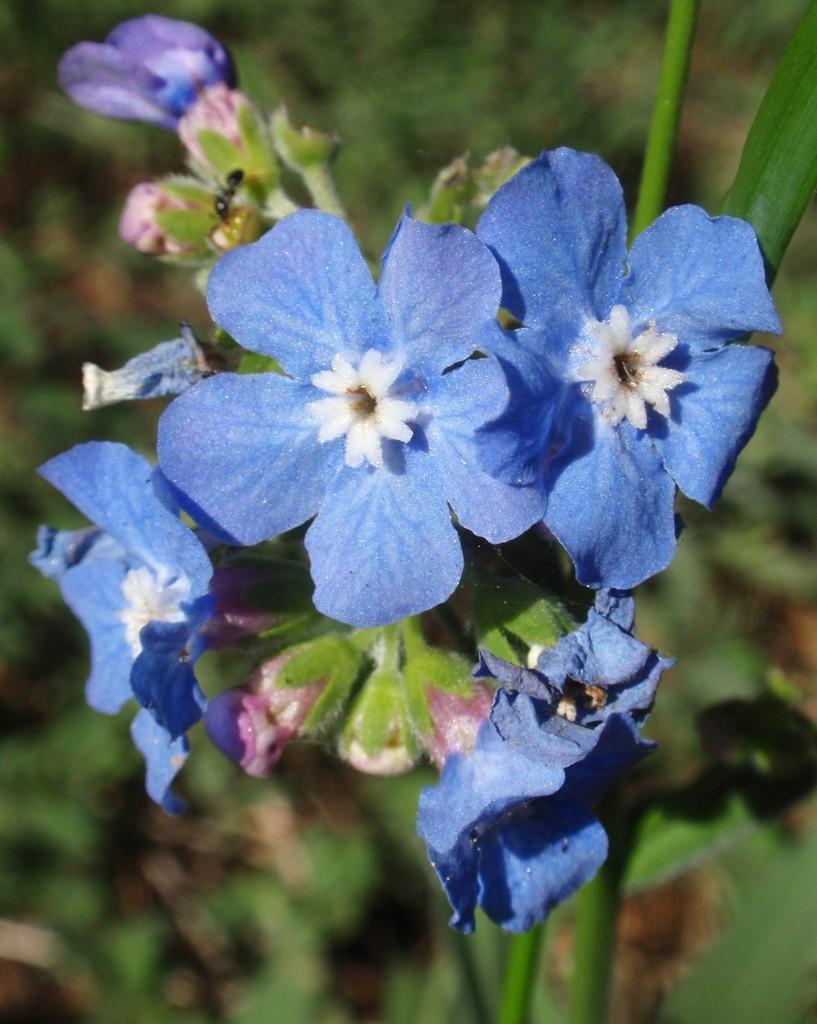In one or two sentences, can you explain what this image depicts? There are blue color flowers and buds on a stem. At the top there is an ant on the flower. In the background it is blurred. 